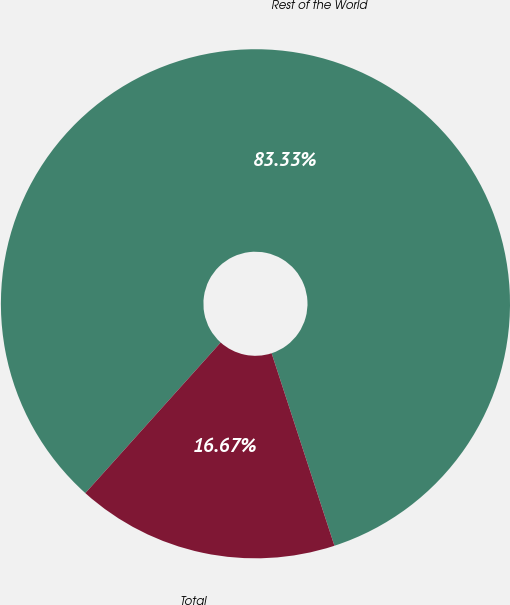Convert chart to OTSL. <chart><loc_0><loc_0><loc_500><loc_500><pie_chart><fcel>Rest of the World<fcel>Total<nl><fcel>83.33%<fcel>16.67%<nl></chart> 